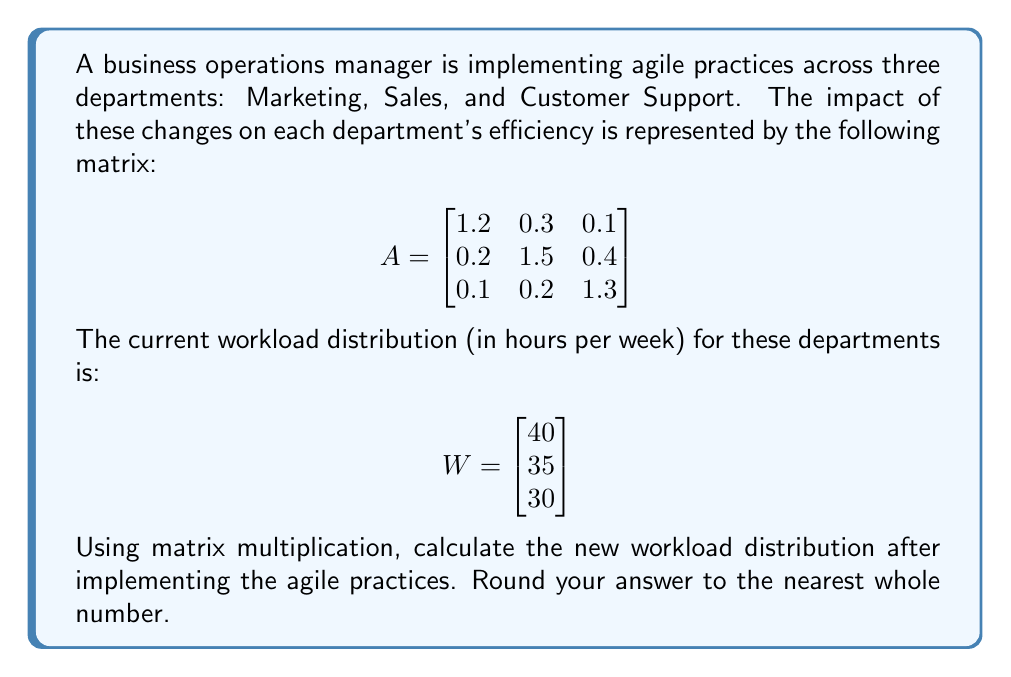Solve this math problem. To solve this problem, we need to multiply the impact matrix A by the current workload vector W. This will give us the new workload distribution after implementing agile practices.

Step 1: Set up the matrix multiplication
$$AW = \begin{bmatrix}
1.2 & 0.3 & 0.1 \\
0.2 & 1.5 & 0.4 \\
0.1 & 0.2 & 1.3
\end{bmatrix} \begin{bmatrix}
40 \\
35 \\
30
\end{bmatrix}$$

Step 2: Perform the matrix multiplication
For the first row:
$(1.2 \times 40) + (0.3 \times 35) + (0.1 \times 30) = 48 + 10.5 + 3 = 61.5$

For the second row:
$(0.2 \times 40) + (1.5 \times 35) + (0.4 \times 30) = 8 + 52.5 + 12 = 72.5$

For the third row:
$(0.1 \times 40) + (0.2 \times 35) + (1.3 \times 30) = 4 + 7 + 39 = 50$

Step 3: Write the result as a matrix
$$AW = \begin{bmatrix}
61.5 \\
72.5 \\
50
\end{bmatrix}$$

Step 4: Round the results to the nearest whole number
$$AW \approx \begin{bmatrix}
62 \\
73 \\
50
\end{bmatrix}$$

This final matrix represents the new workload distribution (in hours per week) for Marketing, Sales, and Customer Support departments, respectively, after implementing agile practices.
Answer: $$\begin{bmatrix}
62 \\
73 \\
50
\end{bmatrix}$$ 